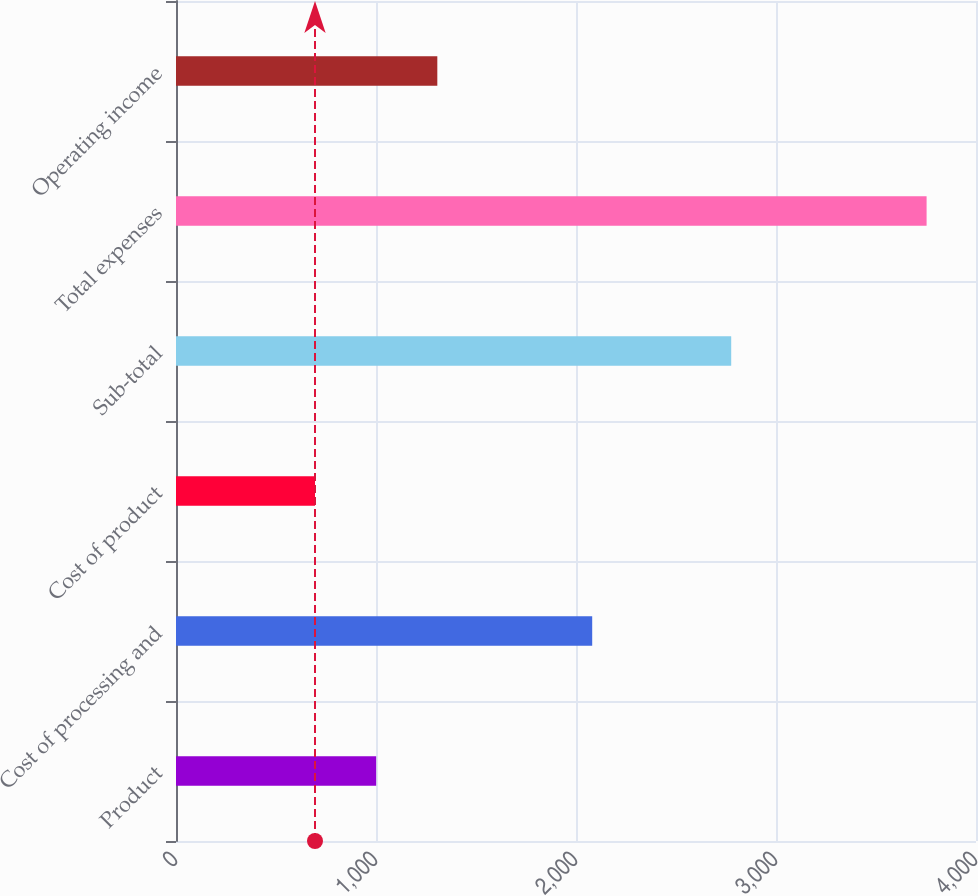<chart> <loc_0><loc_0><loc_500><loc_500><bar_chart><fcel>Product<fcel>Cost of processing and<fcel>Cost of product<fcel>Sub-total<fcel>Total expenses<fcel>Operating income<nl><fcel>1000.8<fcel>2081<fcel>695<fcel>2776<fcel>3753<fcel>1306.6<nl></chart> 